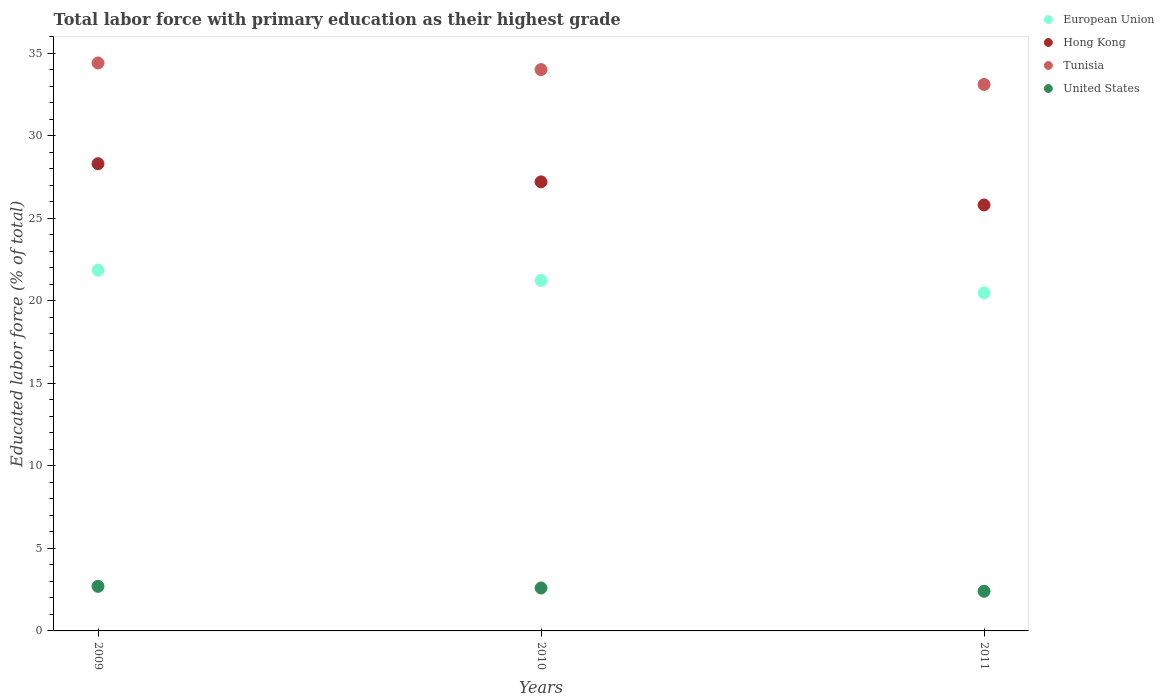What is the percentage of total labor force with primary education in European Union in 2009?
Offer a terse response. 21.85. Across all years, what is the maximum percentage of total labor force with primary education in Tunisia?
Offer a very short reply. 34.4. Across all years, what is the minimum percentage of total labor force with primary education in United States?
Make the answer very short. 2.4. In which year was the percentage of total labor force with primary education in European Union maximum?
Keep it short and to the point. 2009. What is the total percentage of total labor force with primary education in United States in the graph?
Provide a short and direct response. 7.7. What is the difference between the percentage of total labor force with primary education in Hong Kong in 2009 and the percentage of total labor force with primary education in European Union in 2010?
Provide a short and direct response. 7.08. What is the average percentage of total labor force with primary education in Hong Kong per year?
Provide a short and direct response. 27.1. In the year 2009, what is the difference between the percentage of total labor force with primary education in United States and percentage of total labor force with primary education in Tunisia?
Your answer should be compact. -31.7. In how many years, is the percentage of total labor force with primary education in Hong Kong greater than 22 %?
Ensure brevity in your answer.  3. What is the ratio of the percentage of total labor force with primary education in Hong Kong in 2009 to that in 2011?
Provide a short and direct response. 1.1. Is the percentage of total labor force with primary education in Hong Kong in 2009 less than that in 2011?
Ensure brevity in your answer.  No. Is the difference between the percentage of total labor force with primary education in United States in 2009 and 2011 greater than the difference between the percentage of total labor force with primary education in Tunisia in 2009 and 2011?
Give a very brief answer. No. What is the difference between the highest and the second highest percentage of total labor force with primary education in European Union?
Offer a very short reply. 0.62. What is the difference between the highest and the lowest percentage of total labor force with primary education in United States?
Give a very brief answer. 0.3. Is the sum of the percentage of total labor force with primary education in European Union in 2009 and 2010 greater than the maximum percentage of total labor force with primary education in United States across all years?
Give a very brief answer. Yes. Is it the case that in every year, the sum of the percentage of total labor force with primary education in Tunisia and percentage of total labor force with primary education in Hong Kong  is greater than the sum of percentage of total labor force with primary education in United States and percentage of total labor force with primary education in European Union?
Your answer should be very brief. No. Is it the case that in every year, the sum of the percentage of total labor force with primary education in Hong Kong and percentage of total labor force with primary education in European Union  is greater than the percentage of total labor force with primary education in Tunisia?
Provide a short and direct response. Yes. Does the percentage of total labor force with primary education in United States monotonically increase over the years?
Provide a succinct answer. No. Is the percentage of total labor force with primary education in Hong Kong strictly less than the percentage of total labor force with primary education in Tunisia over the years?
Give a very brief answer. Yes. How many dotlines are there?
Your response must be concise. 4. What is the difference between two consecutive major ticks on the Y-axis?
Give a very brief answer. 5. Where does the legend appear in the graph?
Provide a succinct answer. Top right. How many legend labels are there?
Give a very brief answer. 4. How are the legend labels stacked?
Your answer should be compact. Vertical. What is the title of the graph?
Your answer should be very brief. Total labor force with primary education as their highest grade. Does "Belize" appear as one of the legend labels in the graph?
Offer a very short reply. No. What is the label or title of the X-axis?
Offer a very short reply. Years. What is the label or title of the Y-axis?
Provide a short and direct response. Educated labor force (% of total). What is the Educated labor force (% of total) of European Union in 2009?
Offer a very short reply. 21.85. What is the Educated labor force (% of total) of Hong Kong in 2009?
Keep it short and to the point. 28.3. What is the Educated labor force (% of total) of Tunisia in 2009?
Offer a terse response. 34.4. What is the Educated labor force (% of total) in United States in 2009?
Ensure brevity in your answer.  2.7. What is the Educated labor force (% of total) of European Union in 2010?
Your response must be concise. 21.22. What is the Educated labor force (% of total) in Hong Kong in 2010?
Your answer should be very brief. 27.2. What is the Educated labor force (% of total) in United States in 2010?
Your response must be concise. 2.6. What is the Educated labor force (% of total) of European Union in 2011?
Make the answer very short. 20.47. What is the Educated labor force (% of total) in Hong Kong in 2011?
Offer a terse response. 25.8. What is the Educated labor force (% of total) in Tunisia in 2011?
Ensure brevity in your answer.  33.1. What is the Educated labor force (% of total) of United States in 2011?
Your answer should be compact. 2.4. Across all years, what is the maximum Educated labor force (% of total) of European Union?
Provide a short and direct response. 21.85. Across all years, what is the maximum Educated labor force (% of total) in Hong Kong?
Keep it short and to the point. 28.3. Across all years, what is the maximum Educated labor force (% of total) in Tunisia?
Provide a succinct answer. 34.4. Across all years, what is the maximum Educated labor force (% of total) in United States?
Give a very brief answer. 2.7. Across all years, what is the minimum Educated labor force (% of total) of European Union?
Offer a very short reply. 20.47. Across all years, what is the minimum Educated labor force (% of total) in Hong Kong?
Offer a terse response. 25.8. Across all years, what is the minimum Educated labor force (% of total) in Tunisia?
Provide a short and direct response. 33.1. Across all years, what is the minimum Educated labor force (% of total) of United States?
Provide a short and direct response. 2.4. What is the total Educated labor force (% of total) of European Union in the graph?
Keep it short and to the point. 63.55. What is the total Educated labor force (% of total) in Hong Kong in the graph?
Make the answer very short. 81.3. What is the total Educated labor force (% of total) in Tunisia in the graph?
Your response must be concise. 101.5. What is the total Educated labor force (% of total) in United States in the graph?
Offer a terse response. 7.7. What is the difference between the Educated labor force (% of total) in European Union in 2009 and that in 2010?
Your answer should be compact. 0.62. What is the difference between the Educated labor force (% of total) in Hong Kong in 2009 and that in 2010?
Keep it short and to the point. 1.1. What is the difference between the Educated labor force (% of total) of Tunisia in 2009 and that in 2010?
Provide a short and direct response. 0.4. What is the difference between the Educated labor force (% of total) of United States in 2009 and that in 2010?
Offer a very short reply. 0.1. What is the difference between the Educated labor force (% of total) in European Union in 2009 and that in 2011?
Provide a succinct answer. 1.37. What is the difference between the Educated labor force (% of total) of Hong Kong in 2009 and that in 2011?
Your answer should be very brief. 2.5. What is the difference between the Educated labor force (% of total) in Tunisia in 2009 and that in 2011?
Make the answer very short. 1.3. What is the difference between the Educated labor force (% of total) of European Union in 2010 and that in 2011?
Offer a terse response. 0.75. What is the difference between the Educated labor force (% of total) in Hong Kong in 2010 and that in 2011?
Offer a terse response. 1.4. What is the difference between the Educated labor force (% of total) in United States in 2010 and that in 2011?
Your answer should be very brief. 0.2. What is the difference between the Educated labor force (% of total) in European Union in 2009 and the Educated labor force (% of total) in Hong Kong in 2010?
Offer a terse response. -5.35. What is the difference between the Educated labor force (% of total) in European Union in 2009 and the Educated labor force (% of total) in Tunisia in 2010?
Make the answer very short. -12.15. What is the difference between the Educated labor force (% of total) in European Union in 2009 and the Educated labor force (% of total) in United States in 2010?
Your answer should be very brief. 19.25. What is the difference between the Educated labor force (% of total) of Hong Kong in 2009 and the Educated labor force (% of total) of United States in 2010?
Your answer should be compact. 25.7. What is the difference between the Educated labor force (% of total) in Tunisia in 2009 and the Educated labor force (% of total) in United States in 2010?
Your answer should be compact. 31.8. What is the difference between the Educated labor force (% of total) of European Union in 2009 and the Educated labor force (% of total) of Hong Kong in 2011?
Ensure brevity in your answer.  -3.95. What is the difference between the Educated labor force (% of total) in European Union in 2009 and the Educated labor force (% of total) in Tunisia in 2011?
Make the answer very short. -11.25. What is the difference between the Educated labor force (% of total) in European Union in 2009 and the Educated labor force (% of total) in United States in 2011?
Your answer should be compact. 19.45. What is the difference between the Educated labor force (% of total) in Hong Kong in 2009 and the Educated labor force (% of total) in United States in 2011?
Provide a short and direct response. 25.9. What is the difference between the Educated labor force (% of total) in Tunisia in 2009 and the Educated labor force (% of total) in United States in 2011?
Your response must be concise. 32. What is the difference between the Educated labor force (% of total) in European Union in 2010 and the Educated labor force (% of total) in Hong Kong in 2011?
Make the answer very short. -4.58. What is the difference between the Educated labor force (% of total) of European Union in 2010 and the Educated labor force (% of total) of Tunisia in 2011?
Keep it short and to the point. -11.88. What is the difference between the Educated labor force (% of total) of European Union in 2010 and the Educated labor force (% of total) of United States in 2011?
Provide a succinct answer. 18.82. What is the difference between the Educated labor force (% of total) in Hong Kong in 2010 and the Educated labor force (% of total) in Tunisia in 2011?
Your answer should be very brief. -5.9. What is the difference between the Educated labor force (% of total) in Hong Kong in 2010 and the Educated labor force (% of total) in United States in 2011?
Your response must be concise. 24.8. What is the difference between the Educated labor force (% of total) in Tunisia in 2010 and the Educated labor force (% of total) in United States in 2011?
Ensure brevity in your answer.  31.6. What is the average Educated labor force (% of total) of European Union per year?
Make the answer very short. 21.18. What is the average Educated labor force (% of total) in Hong Kong per year?
Provide a succinct answer. 27.1. What is the average Educated labor force (% of total) in Tunisia per year?
Offer a terse response. 33.83. What is the average Educated labor force (% of total) of United States per year?
Offer a very short reply. 2.57. In the year 2009, what is the difference between the Educated labor force (% of total) of European Union and Educated labor force (% of total) of Hong Kong?
Provide a short and direct response. -6.45. In the year 2009, what is the difference between the Educated labor force (% of total) of European Union and Educated labor force (% of total) of Tunisia?
Offer a terse response. -12.55. In the year 2009, what is the difference between the Educated labor force (% of total) in European Union and Educated labor force (% of total) in United States?
Your answer should be very brief. 19.15. In the year 2009, what is the difference between the Educated labor force (% of total) in Hong Kong and Educated labor force (% of total) in United States?
Ensure brevity in your answer.  25.6. In the year 2009, what is the difference between the Educated labor force (% of total) in Tunisia and Educated labor force (% of total) in United States?
Keep it short and to the point. 31.7. In the year 2010, what is the difference between the Educated labor force (% of total) in European Union and Educated labor force (% of total) in Hong Kong?
Your answer should be very brief. -5.97. In the year 2010, what is the difference between the Educated labor force (% of total) of European Union and Educated labor force (% of total) of Tunisia?
Offer a terse response. -12.78. In the year 2010, what is the difference between the Educated labor force (% of total) of European Union and Educated labor force (% of total) of United States?
Ensure brevity in your answer.  18.62. In the year 2010, what is the difference between the Educated labor force (% of total) of Hong Kong and Educated labor force (% of total) of United States?
Your answer should be compact. 24.6. In the year 2010, what is the difference between the Educated labor force (% of total) in Tunisia and Educated labor force (% of total) in United States?
Offer a very short reply. 31.4. In the year 2011, what is the difference between the Educated labor force (% of total) in European Union and Educated labor force (% of total) in Hong Kong?
Your answer should be compact. -5.33. In the year 2011, what is the difference between the Educated labor force (% of total) of European Union and Educated labor force (% of total) of Tunisia?
Give a very brief answer. -12.63. In the year 2011, what is the difference between the Educated labor force (% of total) of European Union and Educated labor force (% of total) of United States?
Keep it short and to the point. 18.07. In the year 2011, what is the difference between the Educated labor force (% of total) in Hong Kong and Educated labor force (% of total) in Tunisia?
Offer a very short reply. -7.3. In the year 2011, what is the difference between the Educated labor force (% of total) in Hong Kong and Educated labor force (% of total) in United States?
Make the answer very short. 23.4. In the year 2011, what is the difference between the Educated labor force (% of total) in Tunisia and Educated labor force (% of total) in United States?
Keep it short and to the point. 30.7. What is the ratio of the Educated labor force (% of total) of European Union in 2009 to that in 2010?
Your answer should be compact. 1.03. What is the ratio of the Educated labor force (% of total) of Hong Kong in 2009 to that in 2010?
Your answer should be compact. 1.04. What is the ratio of the Educated labor force (% of total) in Tunisia in 2009 to that in 2010?
Keep it short and to the point. 1.01. What is the ratio of the Educated labor force (% of total) of European Union in 2009 to that in 2011?
Ensure brevity in your answer.  1.07. What is the ratio of the Educated labor force (% of total) of Hong Kong in 2009 to that in 2011?
Provide a short and direct response. 1.1. What is the ratio of the Educated labor force (% of total) in Tunisia in 2009 to that in 2011?
Your response must be concise. 1.04. What is the ratio of the Educated labor force (% of total) of European Union in 2010 to that in 2011?
Your response must be concise. 1.04. What is the ratio of the Educated labor force (% of total) of Hong Kong in 2010 to that in 2011?
Give a very brief answer. 1.05. What is the ratio of the Educated labor force (% of total) of Tunisia in 2010 to that in 2011?
Provide a succinct answer. 1.03. What is the difference between the highest and the second highest Educated labor force (% of total) of European Union?
Give a very brief answer. 0.62. What is the difference between the highest and the second highest Educated labor force (% of total) of Hong Kong?
Give a very brief answer. 1.1. What is the difference between the highest and the lowest Educated labor force (% of total) of European Union?
Provide a short and direct response. 1.37. What is the difference between the highest and the lowest Educated labor force (% of total) of Tunisia?
Provide a succinct answer. 1.3. What is the difference between the highest and the lowest Educated labor force (% of total) of United States?
Give a very brief answer. 0.3. 